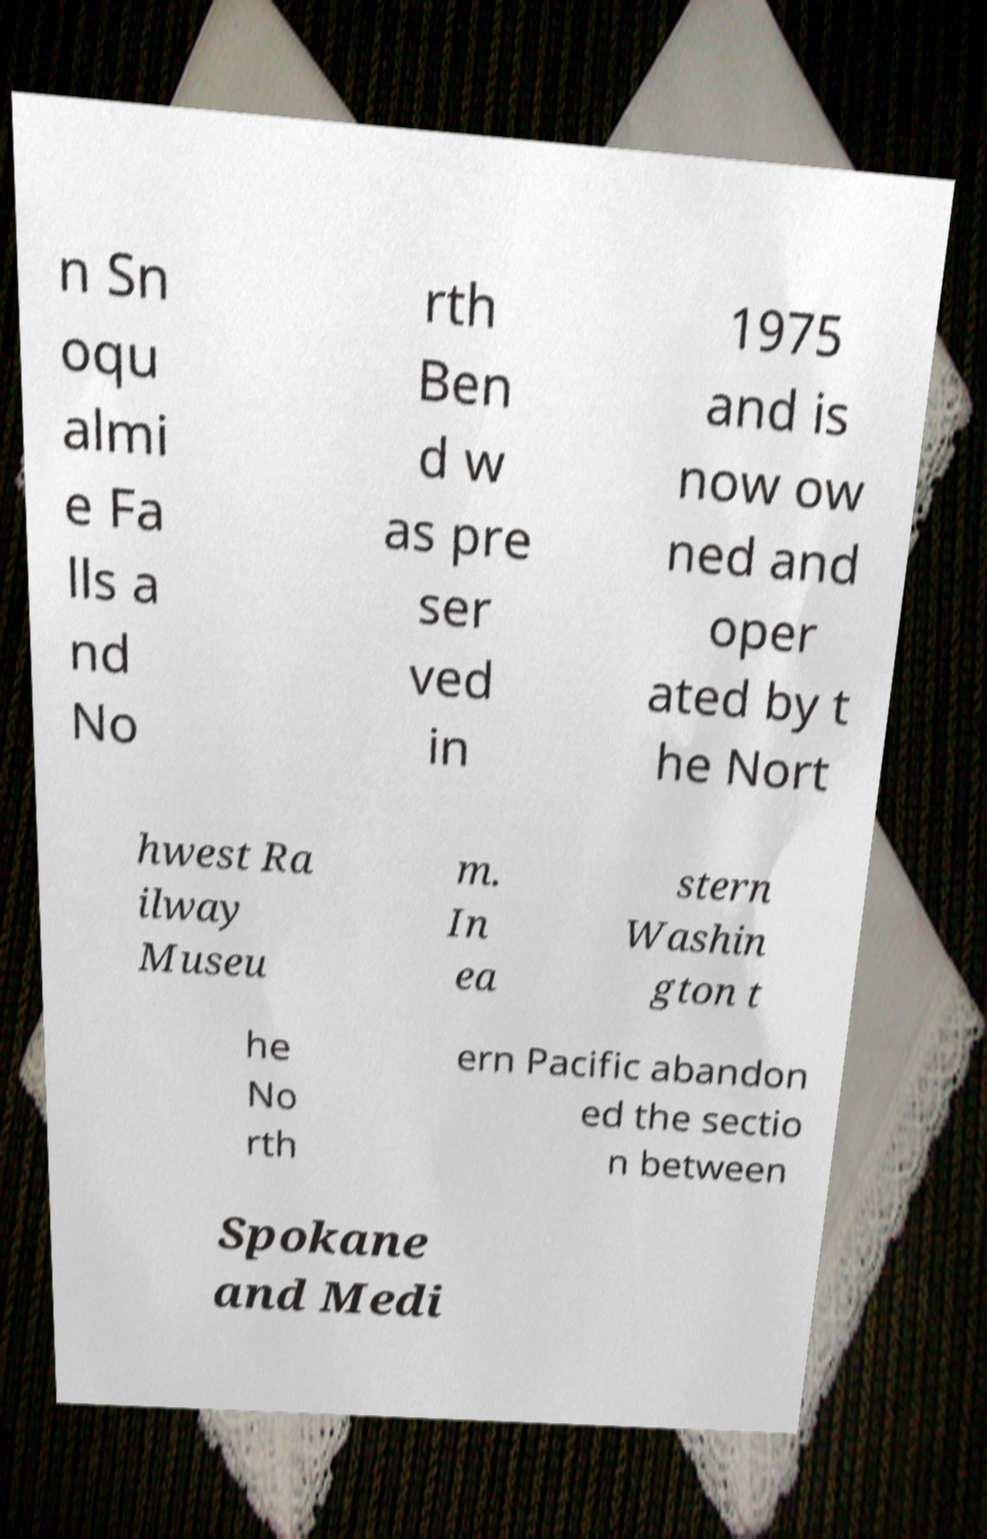There's text embedded in this image that I need extracted. Can you transcribe it verbatim? n Sn oqu almi e Fa lls a nd No rth Ben d w as pre ser ved in 1975 and is now ow ned and oper ated by t he Nort hwest Ra ilway Museu m. In ea stern Washin gton t he No rth ern Pacific abandon ed the sectio n between Spokane and Medi 